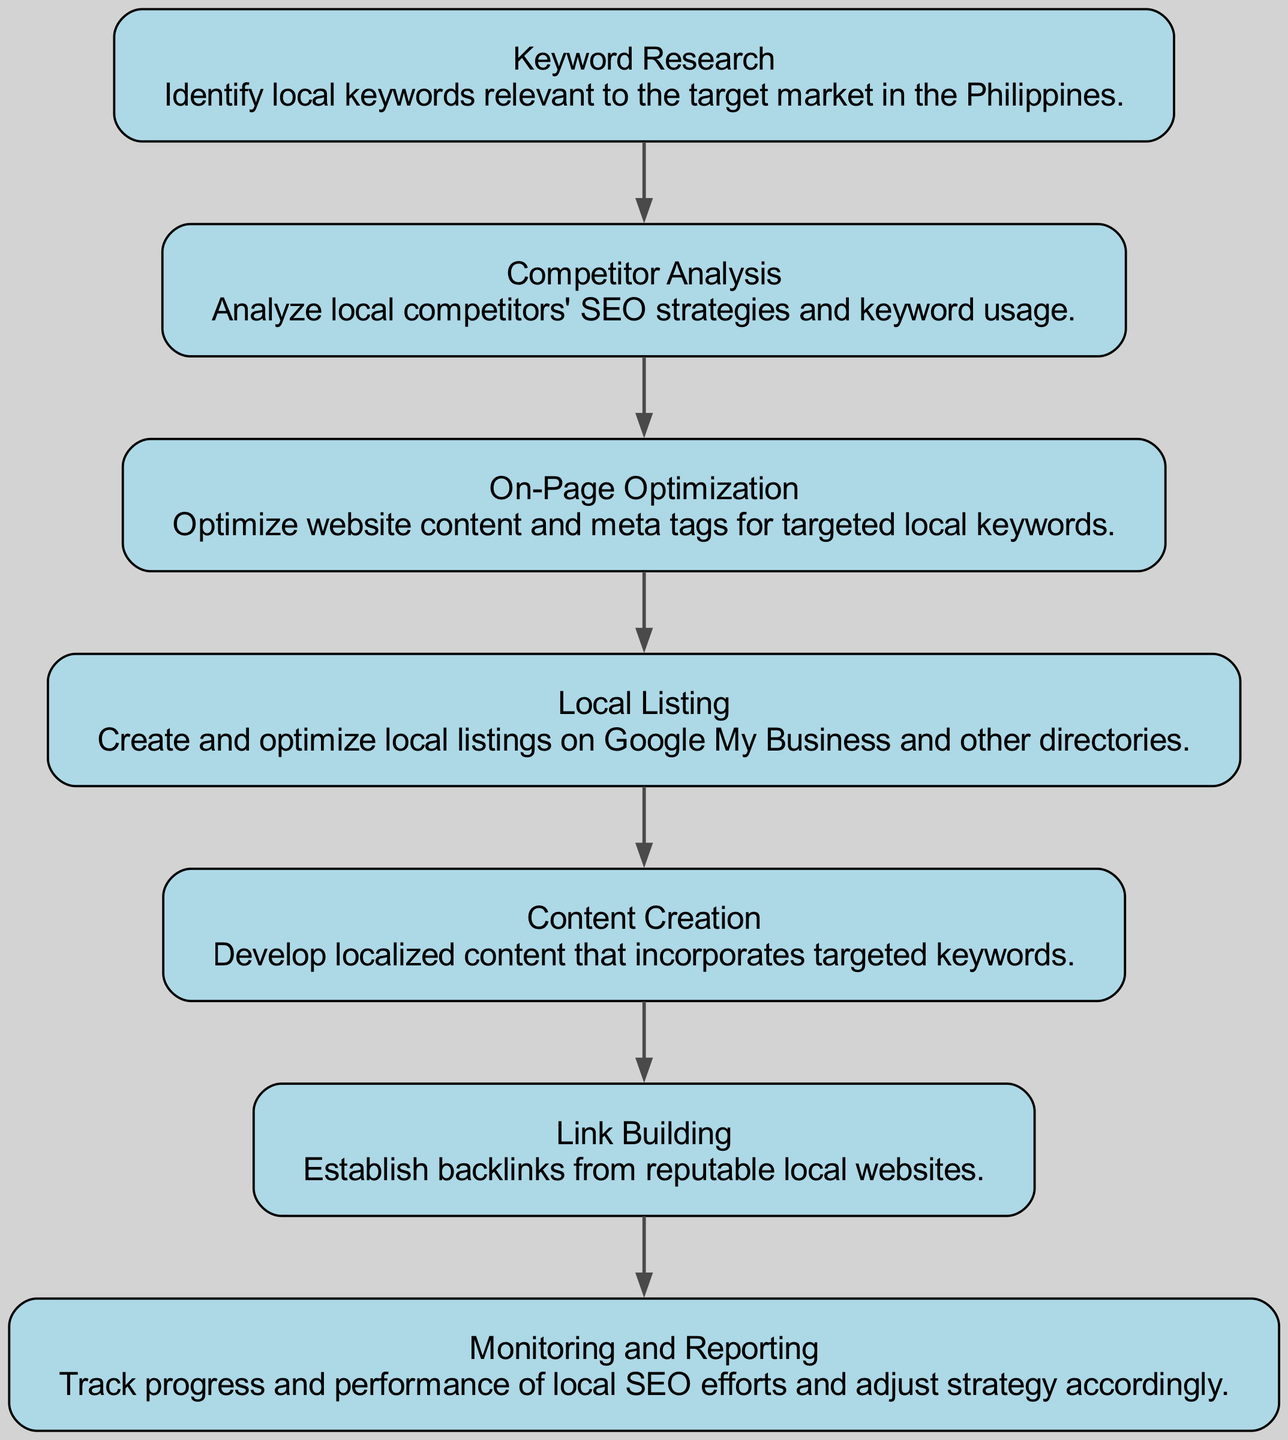What is the first step in the SEO strategy? The first step in the SEO strategy is "Keyword Research," which identifies local keywords relevant to the target market in the Philippines.
Answer: Keyword Research How many nodes are present in the diagram? The diagram contains six nodes representing the different steps in the SEO strategy. These nodes are: Keyword Research, Competitor Analysis, On-Page Optimization, Local Listing, Content Creation, and Link Building.
Answer: Six What follows Competitor Analysis in the implementation timeline? According to the directed graph, "On-Page Optimization" follows "Competitor Analysis." This step focuses on optimizing website content and meta tags for the targeted local keywords.
Answer: On-Page Optimization Which step leads to Content Creation? The step that leads to Content Creation is "Local Listing," which involves creating and optimizing local listings on Google My Business and other directories.
Answer: Local Listing What is the last step in the SEO implementation? The last step in the SEO implementation timeline is "Monitoring and Reporting," which involves tracking progress and performance of local SEO efforts and adjusting the strategy accordingly.
Answer: Monitoring and Reporting How many edges connect the nodes in the diagram? There are five edges in the diagram that connect the nodes in a directed manner, indicating the sequence of steps.
Answer: Five Which node is a prerequisite for Link Building? To engage in "Link Building," the prerequisite node is "Content Creation," as it develops localized content that incorporates targeted keywords needed for building links.
Answer: Content Creation What type of optimization occurs after On-Page Optimization? After "On-Page Optimization" occurs "Local Listing," which focuses on creating and optimizing local online listings.
Answer: Local Listing What is the main focus of the "Competitor Analysis" step? The main focus of "Competitor Analysis" is to analyze local competitors' SEO strategies and keyword usage to inform one's own SEO approach.
Answer: Analyze local competitors' SEO strategies and keyword usage 